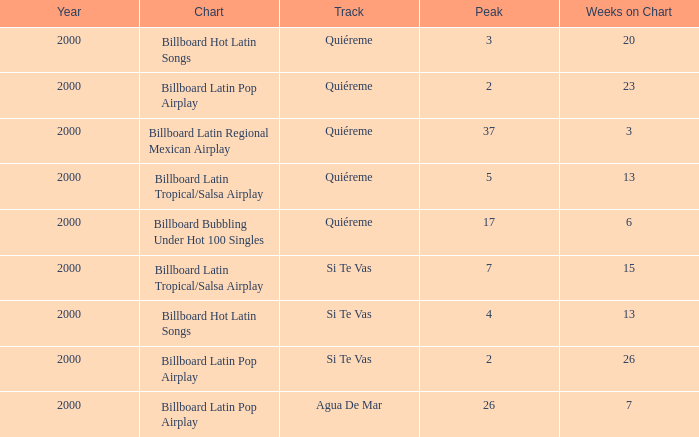Name the total number of weeks for si te vas and peak less than 7 and year less than 2000 0.0. 